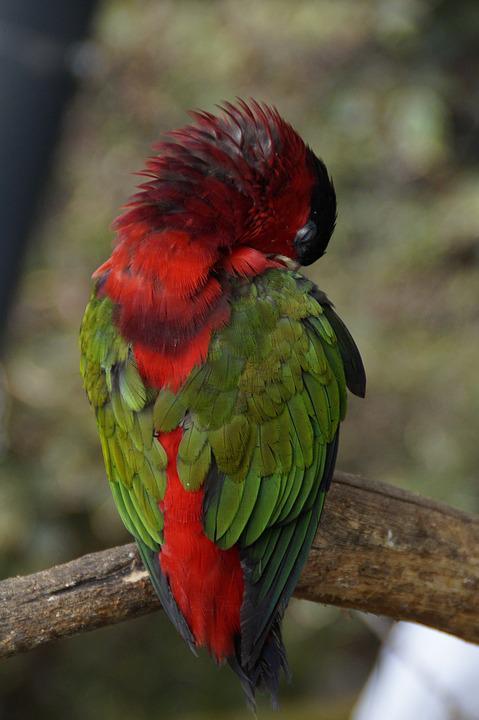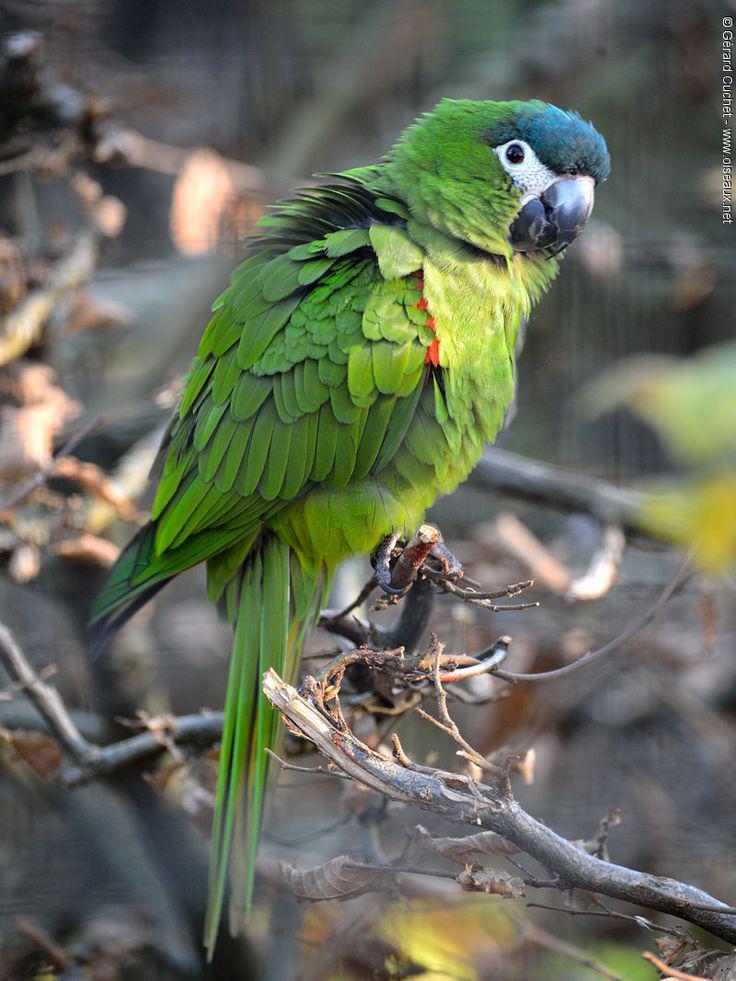The first image is the image on the left, the second image is the image on the right. Examine the images to the left and right. Is the description "A parrot with a red head is sleeping outdoors." accurate? Answer yes or no. Yes. The first image is the image on the left, the second image is the image on the right. For the images displayed, is the sentence "The parrot in the right image has a red head." factually correct? Answer yes or no. No. 